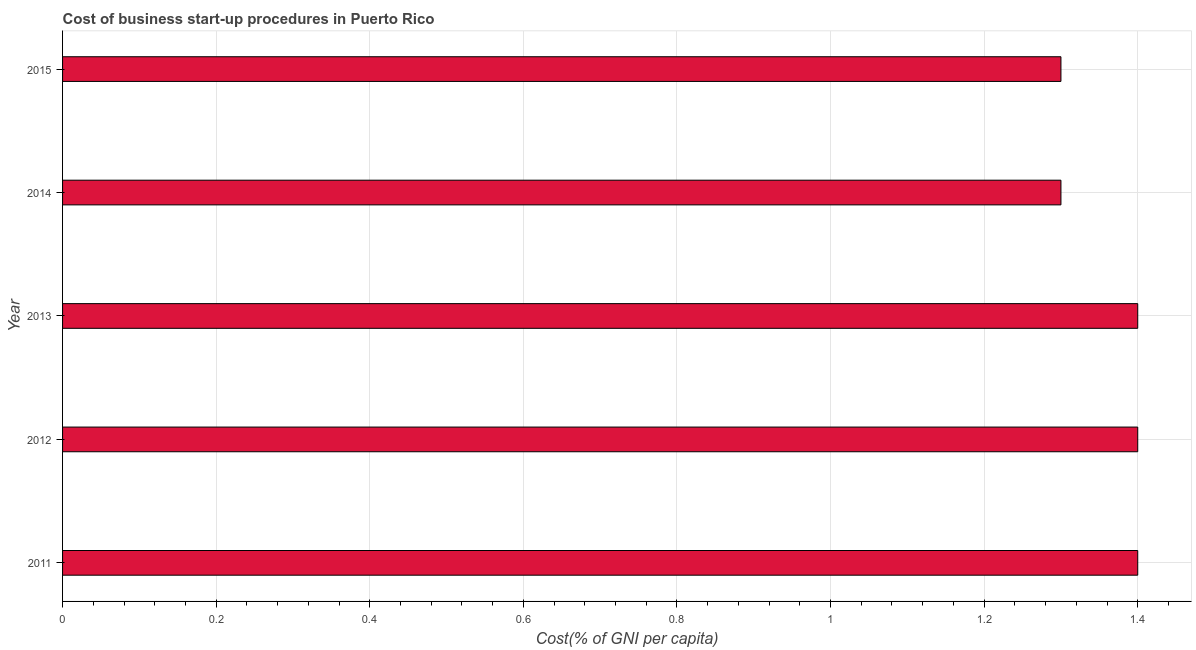Does the graph contain any zero values?
Provide a succinct answer. No. Does the graph contain grids?
Your answer should be very brief. Yes. What is the title of the graph?
Give a very brief answer. Cost of business start-up procedures in Puerto Rico. What is the label or title of the X-axis?
Offer a terse response. Cost(% of GNI per capita). What is the label or title of the Y-axis?
Provide a succinct answer. Year. What is the cost of business startup procedures in 2013?
Your answer should be compact. 1.4. Across all years, what is the maximum cost of business startup procedures?
Offer a very short reply. 1.4. Across all years, what is the minimum cost of business startup procedures?
Give a very brief answer. 1.3. In which year was the cost of business startup procedures maximum?
Keep it short and to the point. 2011. In which year was the cost of business startup procedures minimum?
Provide a succinct answer. 2014. What is the sum of the cost of business startup procedures?
Your answer should be very brief. 6.8. What is the difference between the cost of business startup procedures in 2012 and 2015?
Your answer should be very brief. 0.1. What is the average cost of business startup procedures per year?
Offer a terse response. 1.36. What is the median cost of business startup procedures?
Provide a short and direct response. 1.4. Do a majority of the years between 2015 and 2013 (inclusive) have cost of business startup procedures greater than 1.04 %?
Keep it short and to the point. Yes. What is the ratio of the cost of business startup procedures in 2013 to that in 2014?
Make the answer very short. 1.08. Is the cost of business startup procedures in 2011 less than that in 2015?
Make the answer very short. No. What is the difference between the highest and the second highest cost of business startup procedures?
Give a very brief answer. 0. Is the sum of the cost of business startup procedures in 2013 and 2015 greater than the maximum cost of business startup procedures across all years?
Make the answer very short. Yes. What is the difference between the highest and the lowest cost of business startup procedures?
Offer a terse response. 0.1. Are all the bars in the graph horizontal?
Offer a terse response. Yes. What is the Cost(% of GNI per capita) of 2014?
Offer a terse response. 1.3. What is the Cost(% of GNI per capita) of 2015?
Give a very brief answer. 1.3. What is the difference between the Cost(% of GNI per capita) in 2011 and 2012?
Offer a terse response. 0. What is the difference between the Cost(% of GNI per capita) in 2012 and 2013?
Your answer should be very brief. 0. What is the difference between the Cost(% of GNI per capita) in 2012 and 2014?
Your response must be concise. 0.1. What is the difference between the Cost(% of GNI per capita) in 2013 and 2014?
Provide a short and direct response. 0.1. What is the difference between the Cost(% of GNI per capita) in 2013 and 2015?
Provide a succinct answer. 0.1. What is the ratio of the Cost(% of GNI per capita) in 2011 to that in 2012?
Provide a short and direct response. 1. What is the ratio of the Cost(% of GNI per capita) in 2011 to that in 2013?
Your answer should be very brief. 1. What is the ratio of the Cost(% of GNI per capita) in 2011 to that in 2014?
Offer a terse response. 1.08. What is the ratio of the Cost(% of GNI per capita) in 2011 to that in 2015?
Make the answer very short. 1.08. What is the ratio of the Cost(% of GNI per capita) in 2012 to that in 2013?
Provide a succinct answer. 1. What is the ratio of the Cost(% of GNI per capita) in 2012 to that in 2014?
Offer a very short reply. 1.08. What is the ratio of the Cost(% of GNI per capita) in 2012 to that in 2015?
Make the answer very short. 1.08. What is the ratio of the Cost(% of GNI per capita) in 2013 to that in 2014?
Make the answer very short. 1.08. What is the ratio of the Cost(% of GNI per capita) in 2013 to that in 2015?
Offer a very short reply. 1.08. 